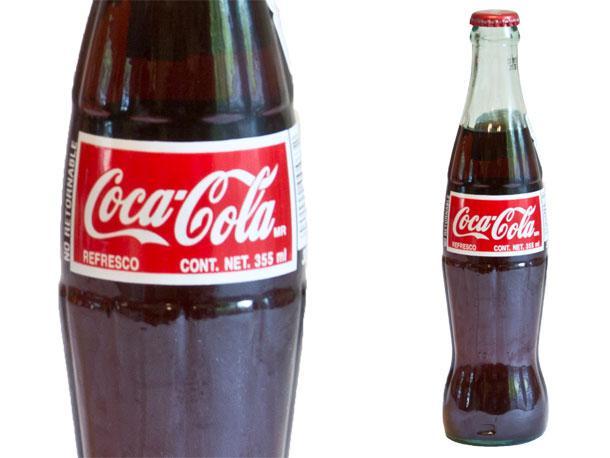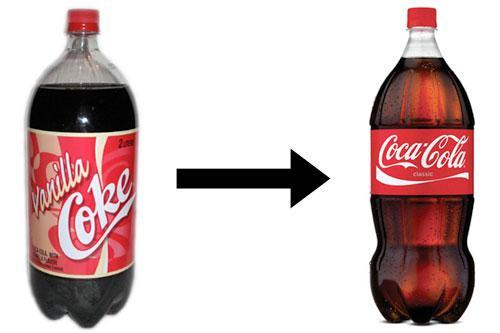The first image is the image on the left, the second image is the image on the right. For the images displayed, is the sentence "The left and right image contains the same number of  bottles." factually correct? Answer yes or no. Yes. The first image is the image on the left, the second image is the image on the right. Considering the images on both sides, is "There are fewer than twelve bottles in total." valid? Answer yes or no. Yes. 